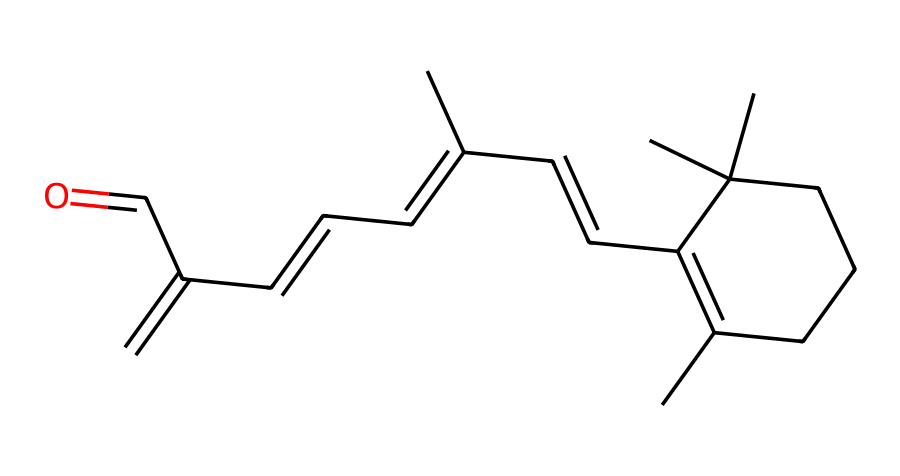What is the molecular formula of retinol? By interpreting the SMILES representation, we can determine the molecular formula of retinol, which consists of 20 carbon atoms, 30 hydrogen atoms, and 1 oxygen atom, leading to the formula C20H30O.
Answer: C20H30O How many rings are present in the structure? Analyzing the SMILES, we can see that there are two occurrences of the digit '1', which indicates the presence of one ring in the structure.
Answer: 1 Which functional group is represented in this chemical? Looking at the end portion of the SMILES, particularly the 'C=O' part, we can identify the carbonyl functional group, indicating an aldehyde at the end of the molecule.
Answer: aldehyde What type of compound is retinol classified as? Since retinol is derived from Vitamin A and has a particular structure with multiple double bonds and an alcohol group, it is classified as a terpenoid, more specifically a polyunsaturated alcohol.
Answer: terpenoid What is the major role of retinol in skincare? The presence of retinol's active forms in skincare products is primarily for promoting cell turnover and reducing visible signs of aging, which is a well-known property of retinol.
Answer: anti-aging Are there any double bonds in the structure? By examining the SMILES, we identify multiple instances of '=C' in the representation, confirming that there are indeed double bonds present.
Answer: yes What specific effect does the aldehyde group have on its properties? The aldehyde group contributes to the reactivity and skincare efficacy by enhancing the compound's ability to penetrate the skin, which is essential for its anti-aging effect.
Answer: enhances penetration 